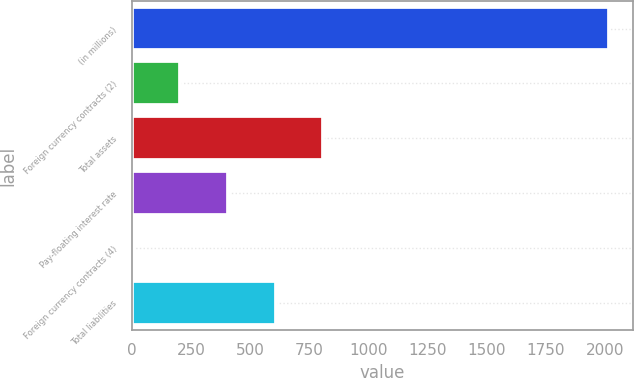Convert chart to OTSL. <chart><loc_0><loc_0><loc_500><loc_500><bar_chart><fcel>(in millions)<fcel>Foreign currency contracts (2)<fcel>Total assets<fcel>Pay-floating interest rate<fcel>Foreign currency contracts (4)<fcel>Total liabilities<nl><fcel>2019<fcel>203.7<fcel>808.8<fcel>405.4<fcel>2<fcel>607.1<nl></chart> 